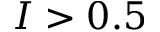<formula> <loc_0><loc_0><loc_500><loc_500>I > 0 . 5</formula> 